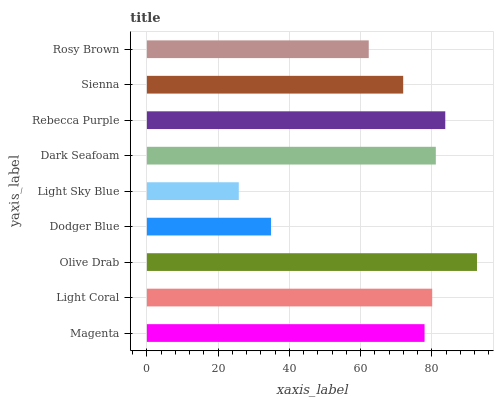Is Light Sky Blue the minimum?
Answer yes or no. Yes. Is Olive Drab the maximum?
Answer yes or no. Yes. Is Light Coral the minimum?
Answer yes or no. No. Is Light Coral the maximum?
Answer yes or no. No. Is Light Coral greater than Magenta?
Answer yes or no. Yes. Is Magenta less than Light Coral?
Answer yes or no. Yes. Is Magenta greater than Light Coral?
Answer yes or no. No. Is Light Coral less than Magenta?
Answer yes or no. No. Is Magenta the high median?
Answer yes or no. Yes. Is Magenta the low median?
Answer yes or no. Yes. Is Rosy Brown the high median?
Answer yes or no. No. Is Dodger Blue the low median?
Answer yes or no. No. 